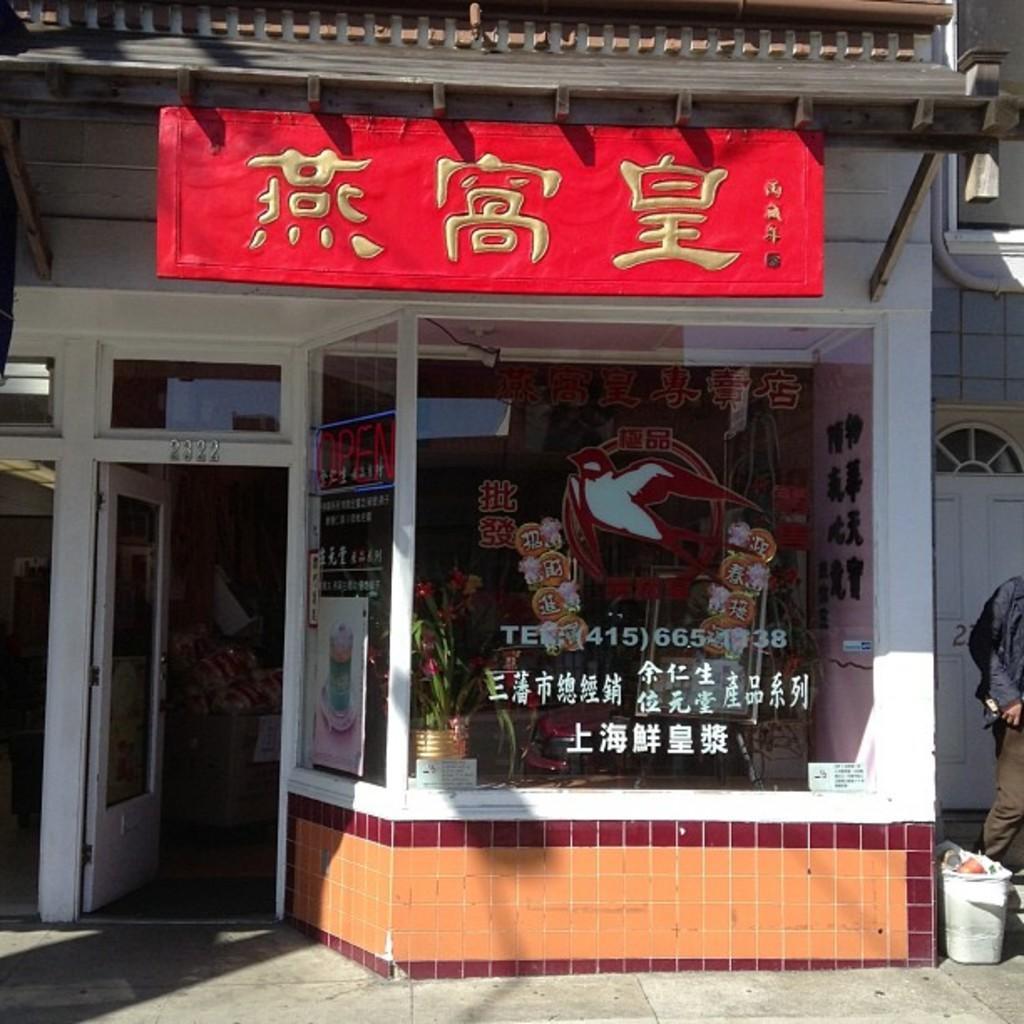Could you give a brief overview of what you see in this image? In the picture we can see a shop with glasses and door with a part of the glass to it and the door is opened and on the top of the shop we can see a red color board with some Chinese words on it. 